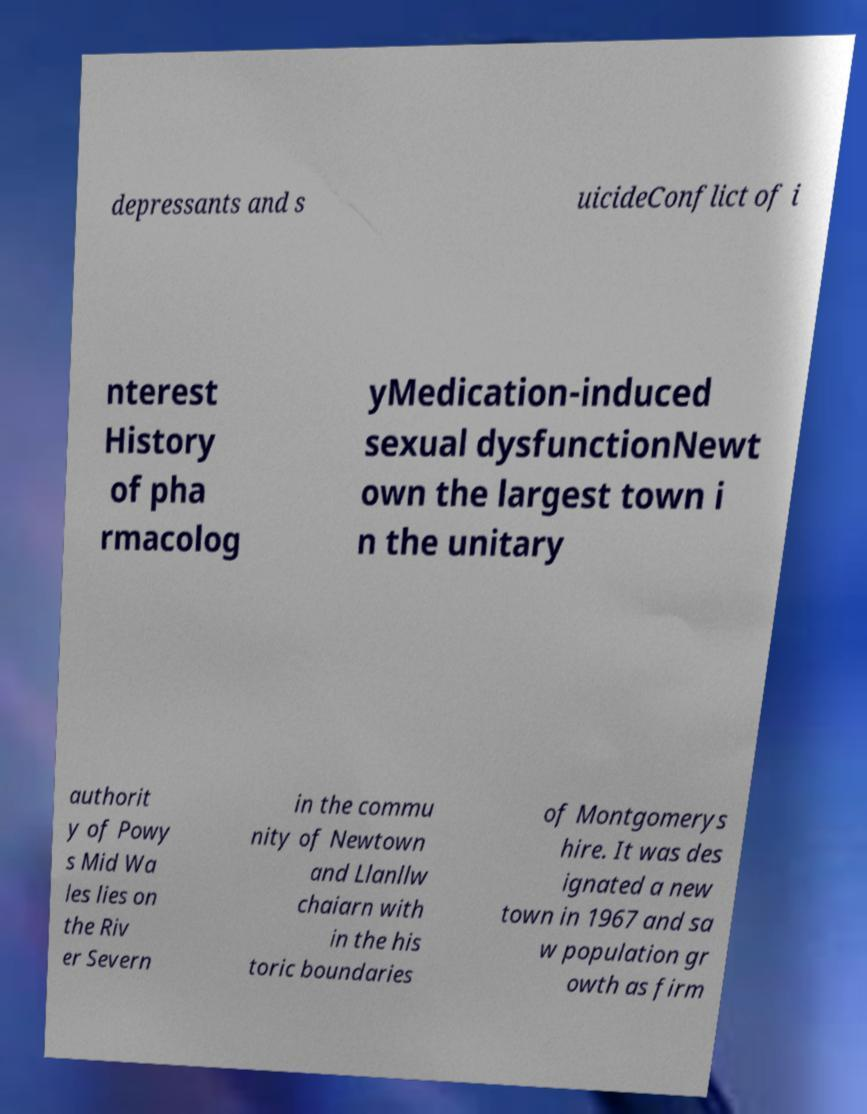There's text embedded in this image that I need extracted. Can you transcribe it verbatim? depressants and s uicideConflict of i nterest History of pha rmacolog yMedication-induced sexual dysfunctionNewt own the largest town i n the unitary authorit y of Powy s Mid Wa les lies on the Riv er Severn in the commu nity of Newtown and Llanllw chaiarn with in the his toric boundaries of Montgomerys hire. It was des ignated a new town in 1967 and sa w population gr owth as firm 